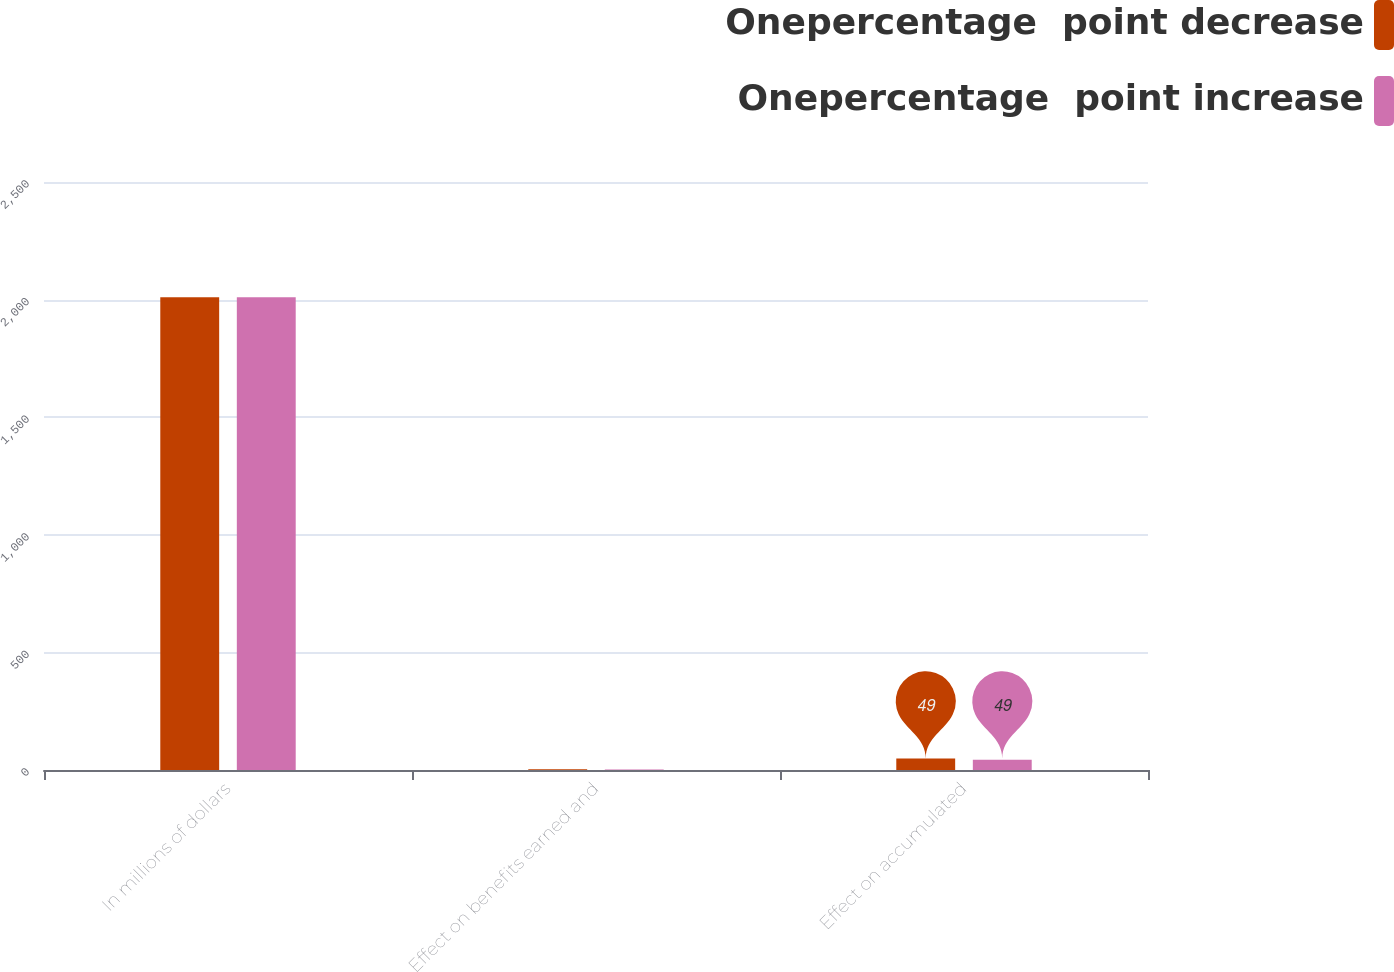Convert chart to OTSL. <chart><loc_0><loc_0><loc_500><loc_500><stacked_bar_chart><ecel><fcel>In millions of dollars<fcel>Effect on benefits earned and<fcel>Effect on accumulated<nl><fcel>Onepercentage  point decrease<fcel>2010<fcel>3<fcel>49<nl><fcel>Onepercentage  point increase<fcel>2010<fcel>2<fcel>44<nl></chart> 